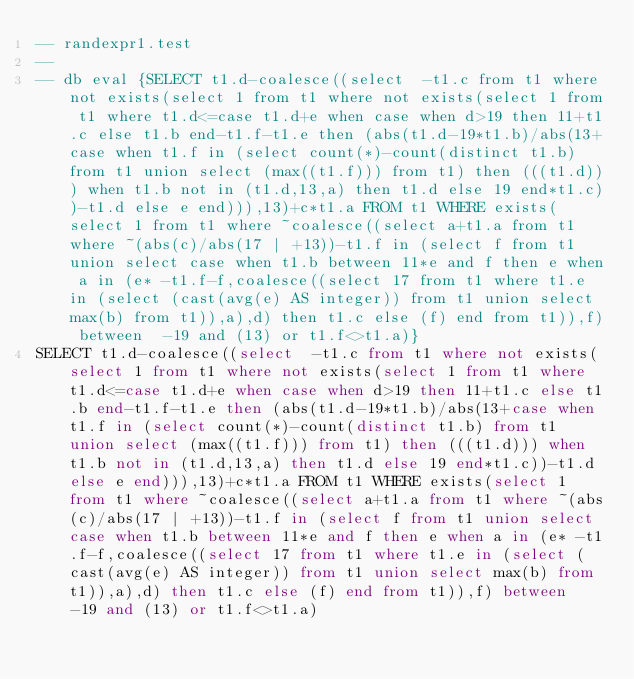<code> <loc_0><loc_0><loc_500><loc_500><_SQL_>-- randexpr1.test
-- 
-- db eval {SELECT t1.d-coalesce((select  -t1.c from t1 where not exists(select 1 from t1 where not exists(select 1 from t1 where t1.d<=case t1.d+e when case when d>19 then 11+t1.c else t1.b end-t1.f-t1.e then (abs(t1.d-19*t1.b)/abs(13+case when t1.f in (select count(*)-count(distinct t1.b) from t1 union select (max((t1.f))) from t1) then (((t1.d))) when t1.b not in (t1.d,13,a) then t1.d else 19 end*t1.c))-t1.d else e end))),13)+c*t1.a FROM t1 WHERE exists(select 1 from t1 where ~coalesce((select a+t1.a from t1 where ~(abs(c)/abs(17 | +13))-t1.f in (select f from t1 union select case when t1.b between 11*e and f then e when a in (e* -t1.f-f,coalesce((select 17 from t1 where t1.e in (select (cast(avg(e) AS integer)) from t1 union select max(b) from t1)),a),d) then t1.c else (f) end from t1)),f) between  -19 and (13) or t1.f<>t1.a)}
SELECT t1.d-coalesce((select  -t1.c from t1 where not exists(select 1 from t1 where not exists(select 1 from t1 where t1.d<=case t1.d+e when case when d>19 then 11+t1.c else t1.b end-t1.f-t1.e then (abs(t1.d-19*t1.b)/abs(13+case when t1.f in (select count(*)-count(distinct t1.b) from t1 union select (max((t1.f))) from t1) then (((t1.d))) when t1.b not in (t1.d,13,a) then t1.d else 19 end*t1.c))-t1.d else e end))),13)+c*t1.a FROM t1 WHERE exists(select 1 from t1 where ~coalesce((select a+t1.a from t1 where ~(abs(c)/abs(17 | +13))-t1.f in (select f from t1 union select case when t1.b between 11*e and f then e when a in (e* -t1.f-f,coalesce((select 17 from t1 where t1.e in (select (cast(avg(e) AS integer)) from t1 union select max(b) from t1)),a),d) then t1.c else (f) end from t1)),f) between  -19 and (13) or t1.f<>t1.a)</code> 